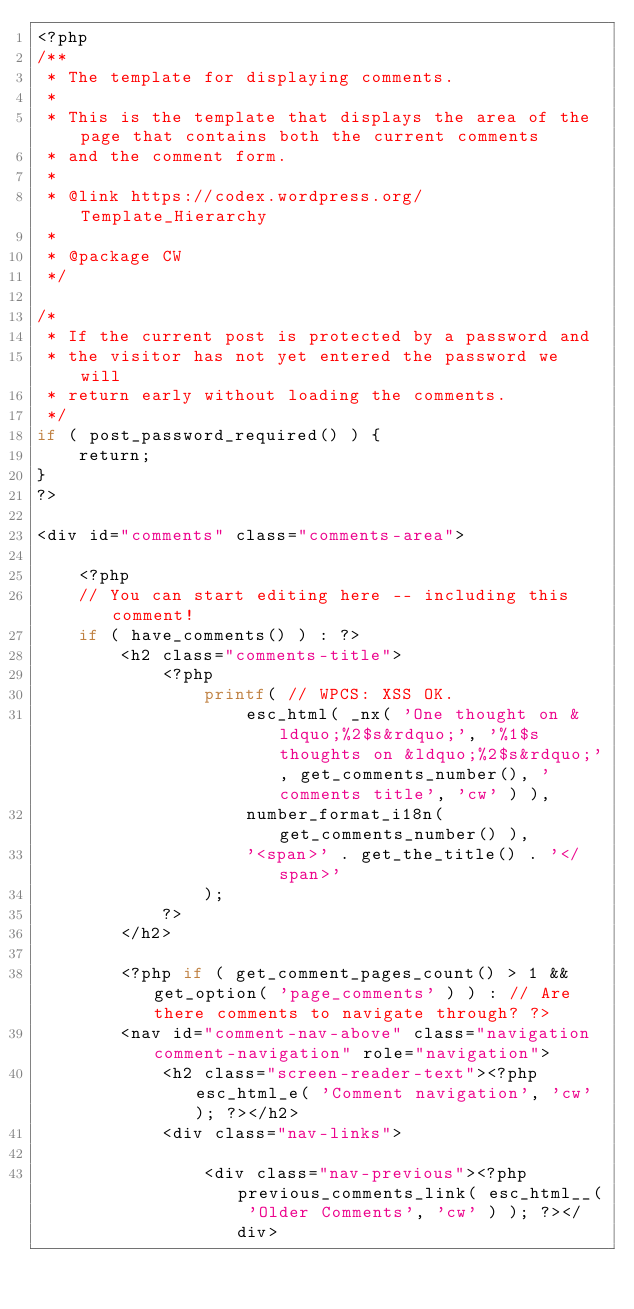Convert code to text. <code><loc_0><loc_0><loc_500><loc_500><_PHP_><?php
/**
 * The template for displaying comments.
 *
 * This is the template that displays the area of the page that contains both the current comments
 * and the comment form.
 *
 * @link https://codex.wordpress.org/Template_Hierarchy
 *
 * @package CW
 */

/*
 * If the current post is protected by a password and
 * the visitor has not yet entered the password we will
 * return early without loading the comments.
 */
if ( post_password_required() ) {
	return;
}
?>

<div id="comments" class="comments-area">

	<?php
	// You can start editing here -- including this comment!
	if ( have_comments() ) : ?>
		<h2 class="comments-title">
			<?php
				printf( // WPCS: XSS OK.
					esc_html( _nx( 'One thought on &ldquo;%2$s&rdquo;', '%1$s thoughts on &ldquo;%2$s&rdquo;', get_comments_number(), 'comments title', 'cw' ) ),
					number_format_i18n( get_comments_number() ),
					'<span>' . get_the_title() . '</span>'
				);
			?>
		</h2>

		<?php if ( get_comment_pages_count() > 1 && get_option( 'page_comments' ) ) : // Are there comments to navigate through? ?>
		<nav id="comment-nav-above" class="navigation comment-navigation" role="navigation">
			<h2 class="screen-reader-text"><?php esc_html_e( 'Comment navigation', 'cw' ); ?></h2>
			<div class="nav-links">

				<div class="nav-previous"><?php previous_comments_link( esc_html__( 'Older Comments', 'cw' ) ); ?></div></code> 